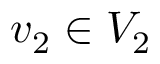Convert formula to latex. <formula><loc_0><loc_0><loc_500><loc_500>v _ { 2 } \in V _ { 2 }</formula> 